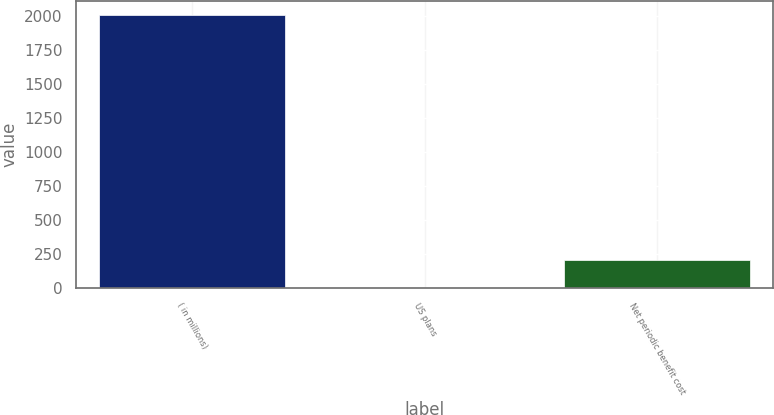Convert chart. <chart><loc_0><loc_0><loc_500><loc_500><bar_chart><fcel>( in millions)<fcel>US plans<fcel>Net periodic benefit cost<nl><fcel>2010<fcel>1.9<fcel>202.71<nl></chart> 